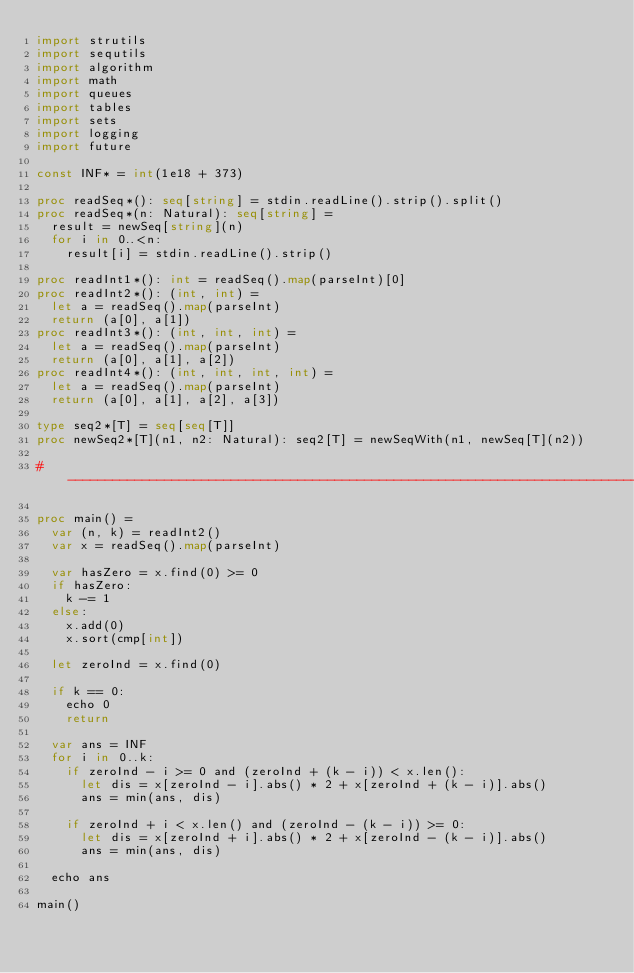Convert code to text. <code><loc_0><loc_0><loc_500><loc_500><_Nim_>import strutils
import sequtils
import algorithm
import math
import queues
import tables
import sets
import logging
import future

const INF* = int(1e18 + 373)

proc readSeq*(): seq[string] = stdin.readLine().strip().split()
proc readSeq*(n: Natural): seq[string] =
  result = newSeq[string](n)
  for i in 0..<n:
    result[i] = stdin.readLine().strip()

proc readInt1*(): int = readSeq().map(parseInt)[0]
proc readInt2*(): (int, int) =
  let a = readSeq().map(parseInt)
  return (a[0], a[1])
proc readInt3*(): (int, int, int) =
  let a = readSeq().map(parseInt)
  return (a[0], a[1], a[2])
proc readInt4*(): (int, int, int, int) =
  let a = readSeq().map(parseInt)
  return (a[0], a[1], a[2], a[3])

type seq2*[T] = seq[seq[T]]
proc newSeq2*[T](n1, n2: Natural): seq2[T] = newSeqWith(n1, newSeq[T](n2))

#------------------------------------------------------------------------------#

proc main() =
  var (n, k) = readInt2()
  var x = readSeq().map(parseInt)

  var hasZero = x.find(0) >= 0
  if hasZero:
    k -= 1
  else:
    x.add(0)
    x.sort(cmp[int])

  let zeroInd = x.find(0)

  if k == 0:
    echo 0
    return

  var ans = INF
  for i in 0..k:
    if zeroInd - i >= 0 and (zeroInd + (k - i)) < x.len():
      let dis = x[zeroInd - i].abs() * 2 + x[zeroInd + (k - i)].abs()
      ans = min(ans, dis)

    if zeroInd + i < x.len() and (zeroInd - (k - i)) >= 0:
      let dis = x[zeroInd + i].abs() * 2 + x[zeroInd - (k - i)].abs()
      ans = min(ans, dis)

  echo ans

main()

</code> 